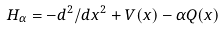Convert formula to latex. <formula><loc_0><loc_0><loc_500><loc_500>H _ { \alpha } = - d ^ { 2 } / d x ^ { 2 } + V ( x ) - \alpha Q ( x )</formula> 